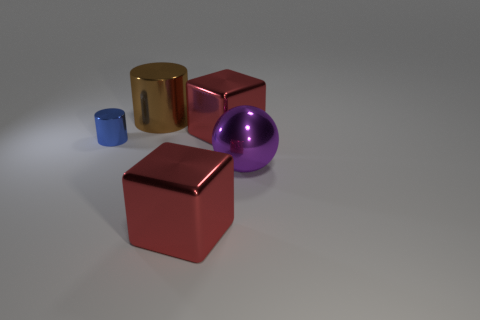Add 3 small brown cylinders. How many objects exist? 8 Subtract all brown cylinders. How many cylinders are left? 1 Subtract 1 cubes. How many cubes are left? 1 Subtract all spheres. How many objects are left? 4 Subtract 1 brown cylinders. How many objects are left? 4 Subtract all gray cubes. Subtract all red spheres. How many cubes are left? 2 Subtract all yellow spheres. How many blue cylinders are left? 1 Subtract all yellow shiny blocks. Subtract all small cylinders. How many objects are left? 4 Add 5 big objects. How many big objects are left? 9 Add 2 cylinders. How many cylinders exist? 4 